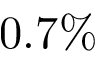Convert formula to latex. <formula><loc_0><loc_0><loc_500><loc_500>0 . 7 \%</formula> 